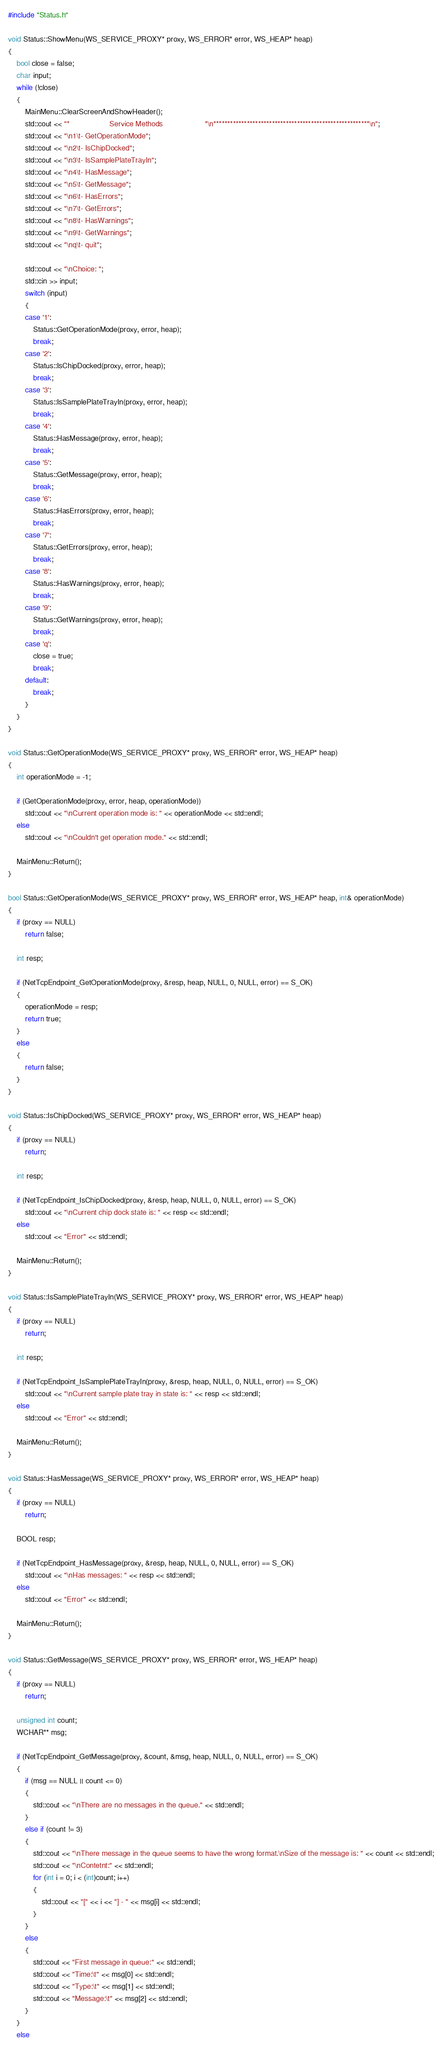Convert code to text. <code><loc_0><loc_0><loc_500><loc_500><_C++_>#include "Status.h"

void Status::ShowMenu(WS_SERVICE_PROXY* proxy, WS_ERROR* error, WS_HEAP* heap)
{
	bool close = false;
	char input;
	while (!close)
	{
		MainMenu::ClearScreenAndShowHeader();
		std::cout << "*                   Service Methods                    *\n********************************************************\n";
		std::cout << "\n1\t- GetOperationMode";
		std::cout << "\n2\t- IsChipDocked";
		std::cout << "\n3\t- IsSamplePlateTrayIn";
		std::cout << "\n4\t- HasMessage";
		std::cout << "\n5\t- GetMessage";
		std::cout << "\n6\t- HasErrors";
		std::cout << "\n7\t- GetErrors";
		std::cout << "\n8\t- HasWarnings";
		std::cout << "\n9\t- GetWarnings";
		std::cout << "\nq\t- quit";

		std::cout << "\nChoice: ";
		std::cin >> input;
		switch (input)
		{
		case '1':
			Status::GetOperationMode(proxy, error, heap);
			break;
		case '2':
			Status::IsChipDocked(proxy, error, heap);
			break;
		case '3':
			Status::IsSamplePlateTrayIn(proxy, error, heap);
			break;
		case '4':
			Status::HasMessage(proxy, error, heap);
			break;
		case '5':
			Status::GetMessage(proxy, error, heap);
			break;
		case '6':
			Status::HasErrors(proxy, error, heap);
			break;
		case '7':
			Status::GetErrors(proxy, error, heap);
			break;
		case '8':
			Status::HasWarnings(proxy, error, heap);
			break;
		case '9':
			Status::GetWarnings(proxy, error, heap);
			break;
		case 'q':
			close = true;
			break;
		default:
			break;
		}
	}
}

void Status::GetOperationMode(WS_SERVICE_PROXY* proxy, WS_ERROR* error, WS_HEAP* heap)
{
	int operationMode = -1;

	if (GetOperationMode(proxy, error, heap, operationMode))
		std::cout << "\nCurrent operation mode is: " << operationMode << std::endl;
	else
		std::cout << "\nCouldn't get operation mode." << std::endl;

	MainMenu::Return();
}

bool Status::GetOperationMode(WS_SERVICE_PROXY* proxy, WS_ERROR* error, WS_HEAP* heap, int& operationMode)
{
	if (proxy == NULL)
		return false;

	int resp;

	if (NetTcpEndpoint_GetOperationMode(proxy, &resp, heap, NULL, 0, NULL, error) == S_OK)
	{
		operationMode = resp;
		return true;
	}
	else
	{
		return false;
	}
}

void Status::IsChipDocked(WS_SERVICE_PROXY* proxy, WS_ERROR* error, WS_HEAP* heap)
{
	if (proxy == NULL)
		return;

	int resp;

	if (NetTcpEndpoint_IsChipDocked(proxy, &resp, heap, NULL, 0, NULL, error) == S_OK)
		std::cout << "\nCurrent chip dock state is: " << resp << std::endl;
	else
		std::cout << "Error" << std::endl;

	MainMenu::Return();
}

void Status::IsSamplePlateTrayIn(WS_SERVICE_PROXY* proxy, WS_ERROR* error, WS_HEAP* heap)
{
	if (proxy == NULL)
		return;

	int resp;

	if (NetTcpEndpoint_IsSamplePlateTrayIn(proxy, &resp, heap, NULL, 0, NULL, error) == S_OK)
		std::cout << "\nCurrent sample plate tray in state is: " << resp << std::endl;
	else
		std::cout << "Error" << std::endl;

	MainMenu::Return();
}

void Status::HasMessage(WS_SERVICE_PROXY* proxy, WS_ERROR* error, WS_HEAP* heap)
{
	if (proxy == NULL)
		return;

	BOOL resp;

	if (NetTcpEndpoint_HasMessage(proxy, &resp, heap, NULL, 0, NULL, error) == S_OK)
		std::cout << "\nHas messages: " << resp << std::endl;
	else
		std::cout << "Error" << std::endl;

	MainMenu::Return();
}

void Status::GetMessage(WS_SERVICE_PROXY* proxy, WS_ERROR* error, WS_HEAP* heap)
{
	if (proxy == NULL)
		return;

	unsigned int count;
	WCHAR** msg;

	if (NetTcpEndpoint_GetMessage(proxy, &count, &msg, heap, NULL, 0, NULL, error) == S_OK)
	{
		if (msg == NULL || count <= 0)
		{
			std::cout << "\nThere are no messages in the queue." << std::endl;
		}
		else if (count != 3)
		{
			std::cout << "\nThere message in the queue seems to have the wrong format.\nSize of the message is: " << count << std::endl;
			std::cout << "\nContetnt:" << std::endl;
			for (int i = 0; i < (int)count; i++)
			{
				std::cout << "[" << i << "] - " << msg[i] << std::endl;
			}
		}
		else
		{
			std::cout << "First message in queue:" << std::endl;
			std::cout << "Time:\t" << msg[0] << std::endl;
			std::cout << "Type:\t" << msg[1] << std::endl;
			std::cout << "Message:\t" << msg[2] << std::endl;
		}
	}
	else</code> 